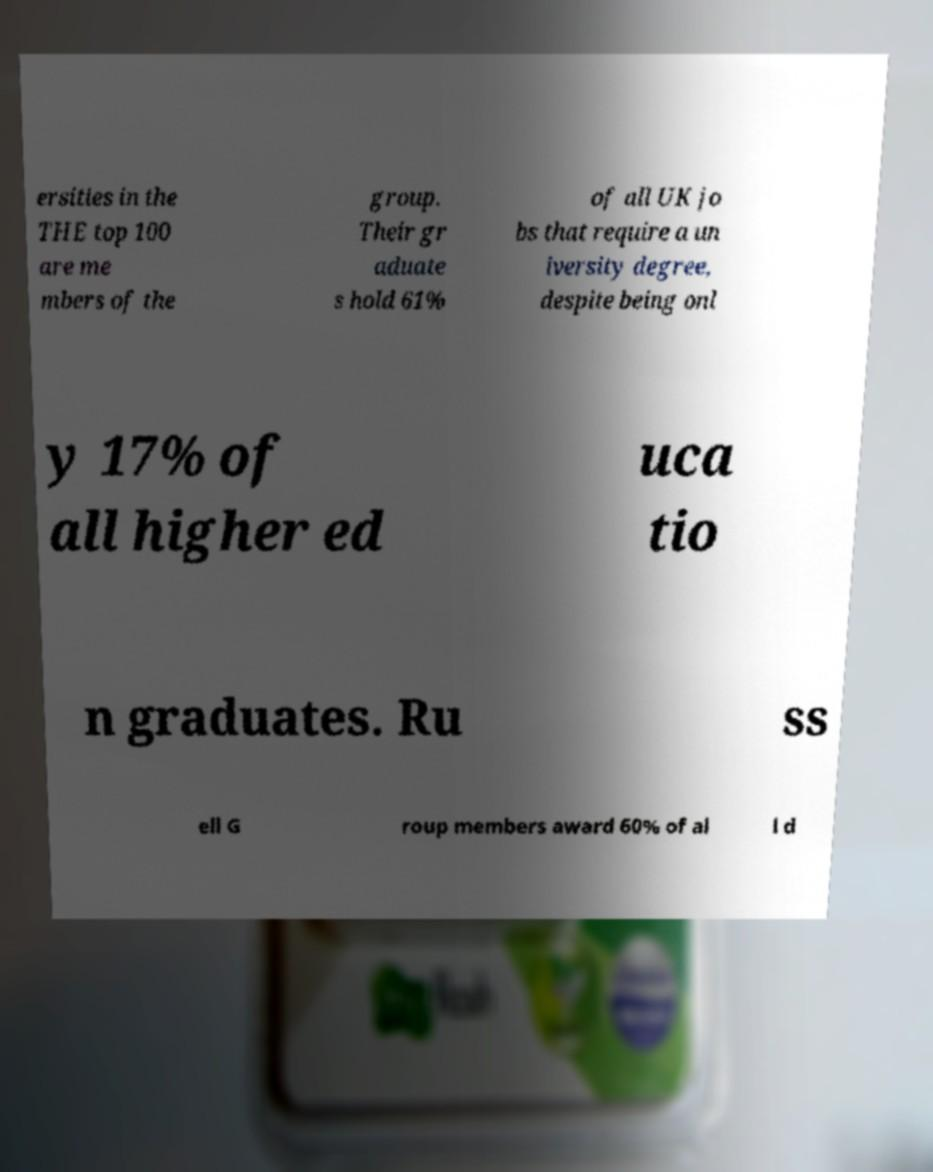Can you accurately transcribe the text from the provided image for me? ersities in the THE top 100 are me mbers of the group. Their gr aduate s hold 61% of all UK jo bs that require a un iversity degree, despite being onl y 17% of all higher ed uca tio n graduates. Ru ss ell G roup members award 60% of al l d 